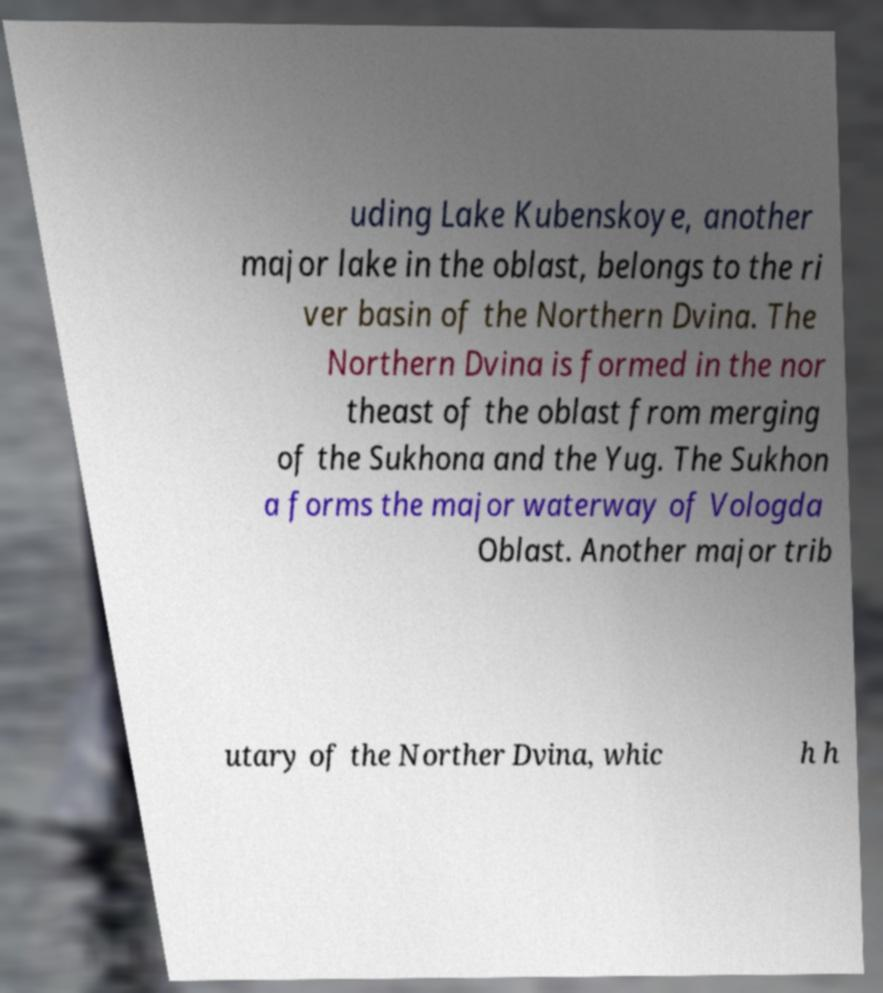Can you accurately transcribe the text from the provided image for me? uding Lake Kubenskoye, another major lake in the oblast, belongs to the ri ver basin of the Northern Dvina. The Northern Dvina is formed in the nor theast of the oblast from merging of the Sukhona and the Yug. The Sukhon a forms the major waterway of Vologda Oblast. Another major trib utary of the Norther Dvina, whic h h 